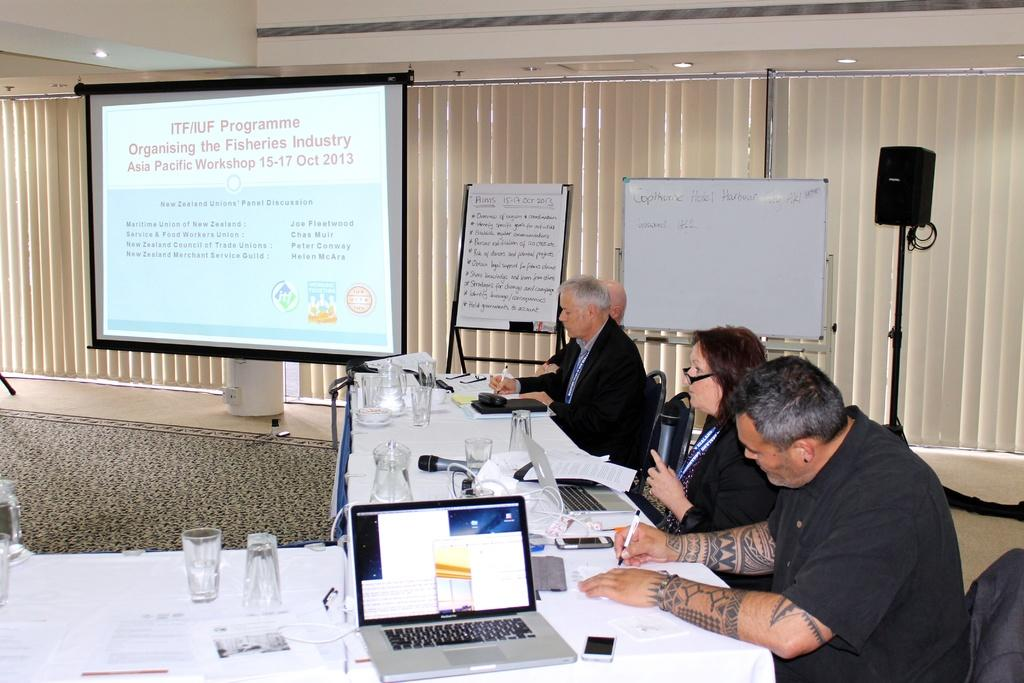<image>
Create a compact narrative representing the image presented. People are at a meeting about the ITF/IUF Programme. 